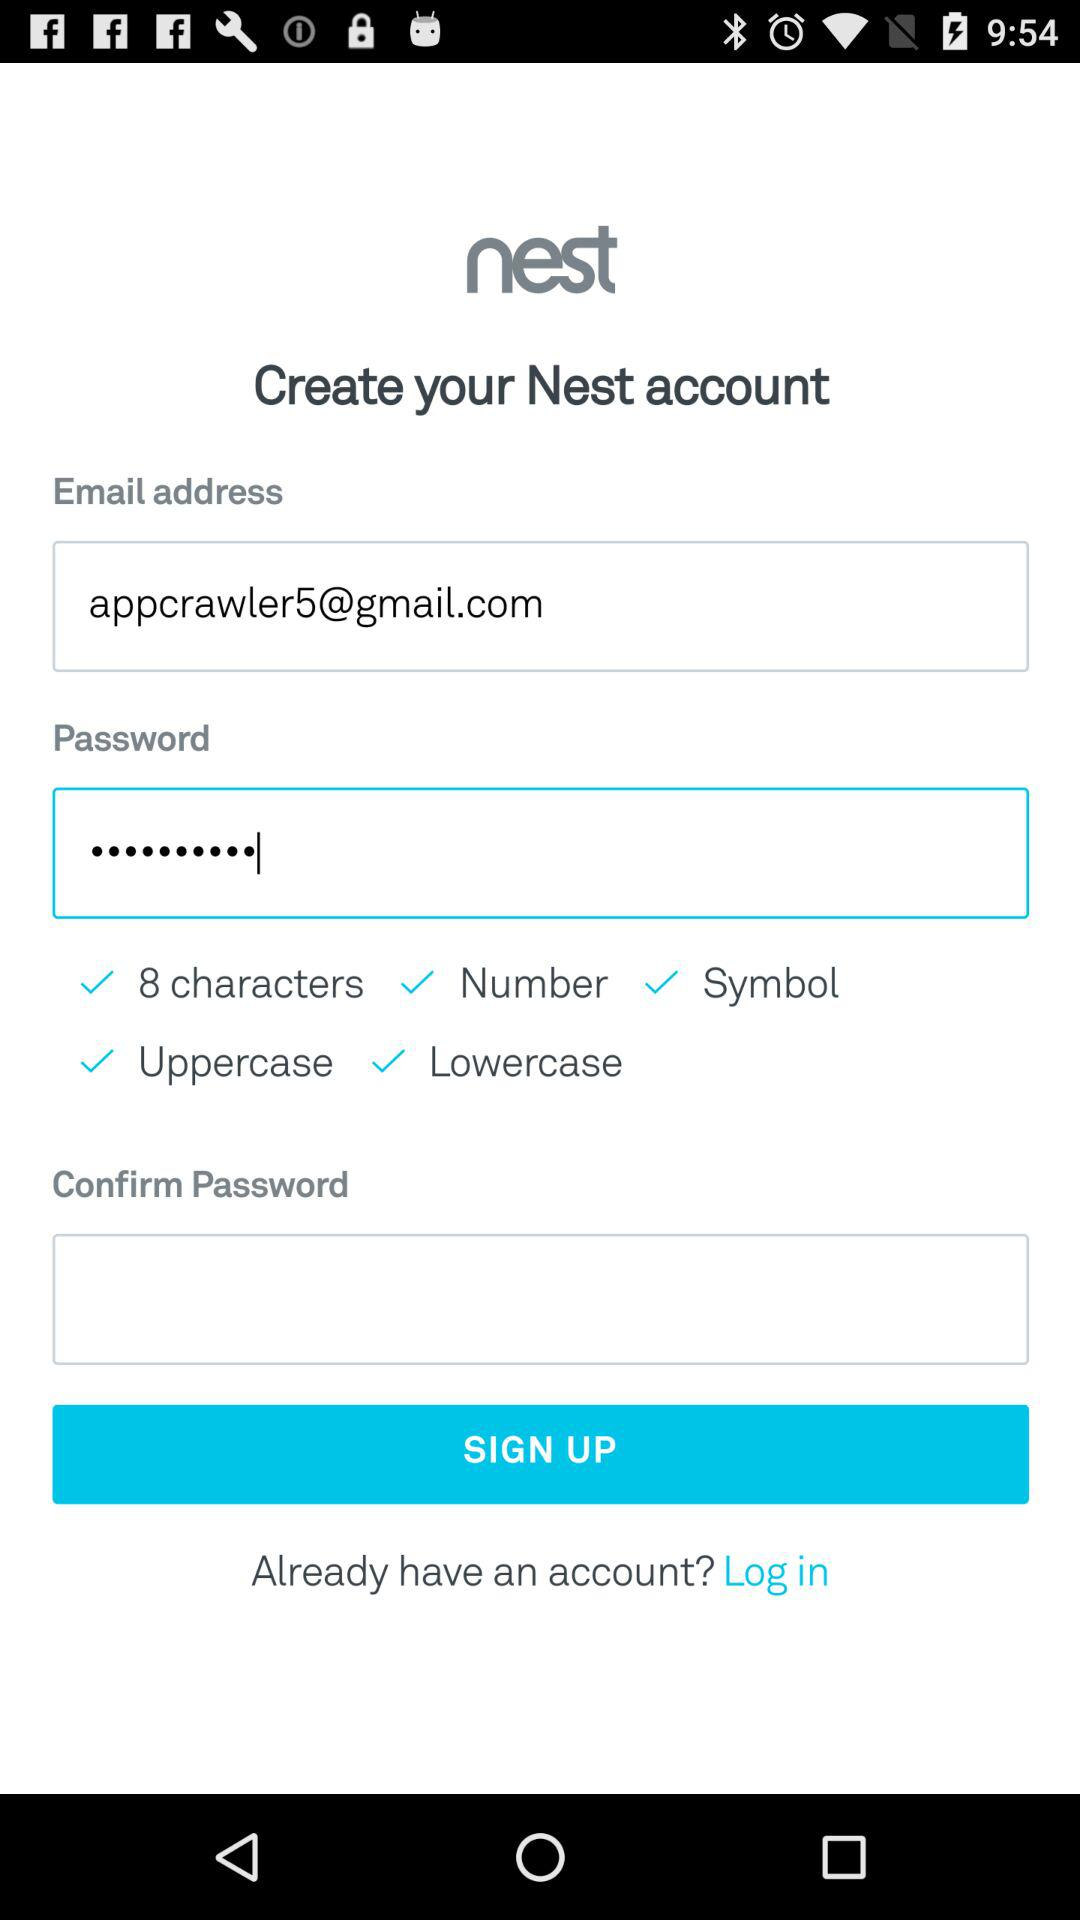What are the criteria for setting a password? The criteria for setting a password are "8 characters", "Number", "Symbol", "Uppercase" and "Lowercase". 